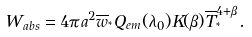Convert formula to latex. <formula><loc_0><loc_0><loc_500><loc_500>W _ { a b s } = 4 \pi a ^ { 2 } \overline { w } _ { ^ { * } } Q _ { e m } ( \lambda _ { 0 } ) K ( \beta ) \overline { T } _ { ^ { * } } ^ { 4 + \beta } .</formula> 